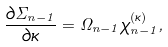Convert formula to latex. <formula><loc_0><loc_0><loc_500><loc_500>\frac { \partial \Sigma _ { n - 1 } } { \partial \kappa } = \Omega _ { n - 1 } \chi _ { n - 1 } ^ { ( \kappa ) } ,</formula> 